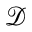Convert formula to latex. <formula><loc_0><loc_0><loc_500><loc_500>\mathcal { D }</formula> 